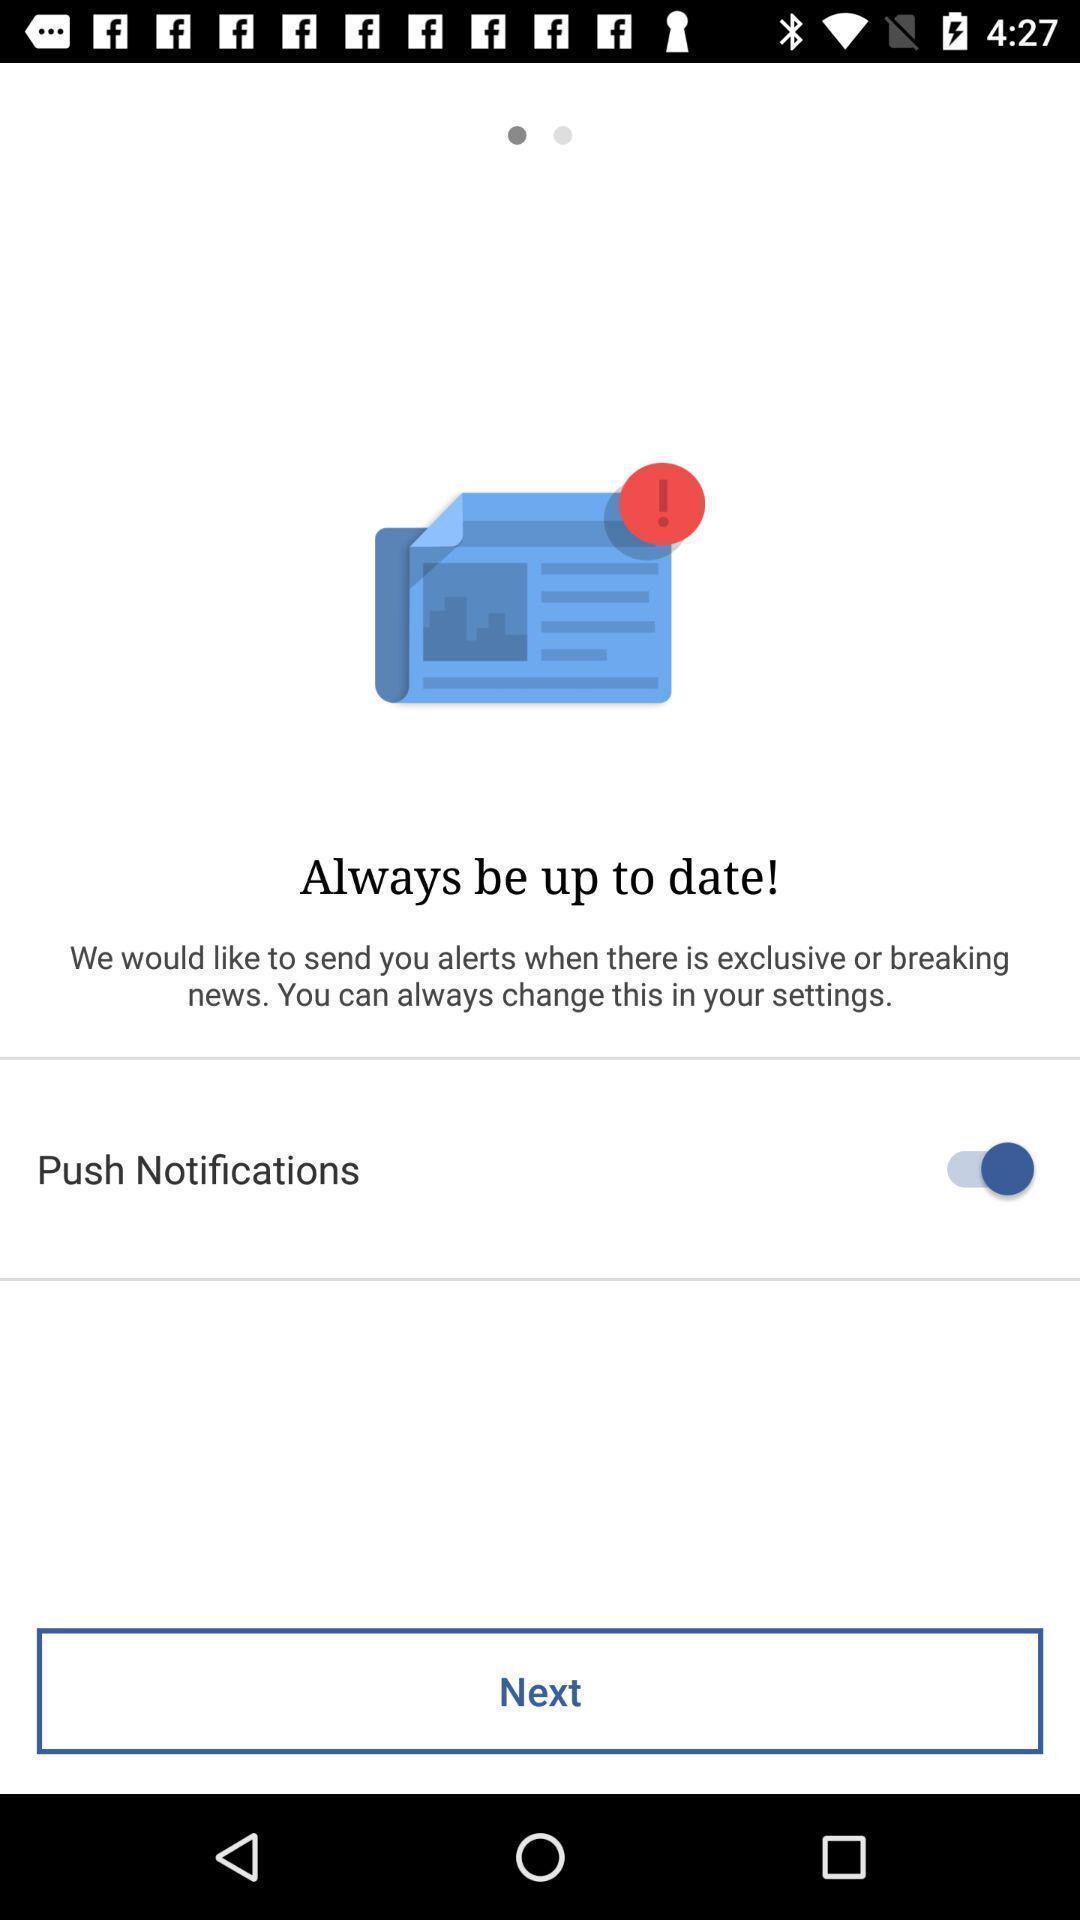Tell me about the visual elements in this screen capture. Screen shows push notifications option. 